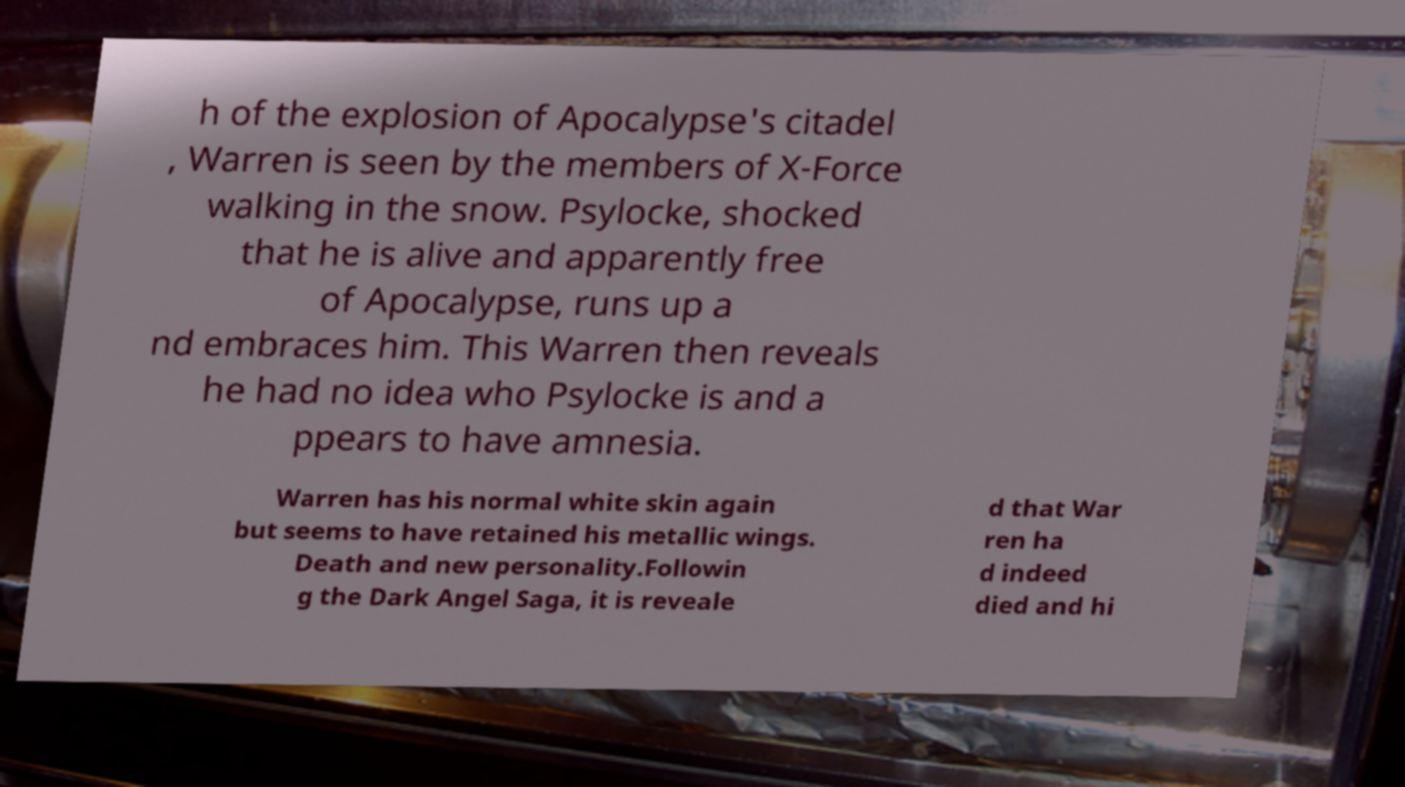Can you read and provide the text displayed in the image?This photo seems to have some interesting text. Can you extract and type it out for me? h of the explosion of Apocalypse's citadel , Warren is seen by the members of X-Force walking in the snow. Psylocke, shocked that he is alive and apparently free of Apocalypse, runs up a nd embraces him. This Warren then reveals he had no idea who Psylocke is and a ppears to have amnesia. Warren has his normal white skin again but seems to have retained his metallic wings. Death and new personality.Followin g the Dark Angel Saga, it is reveale d that War ren ha d indeed died and hi 